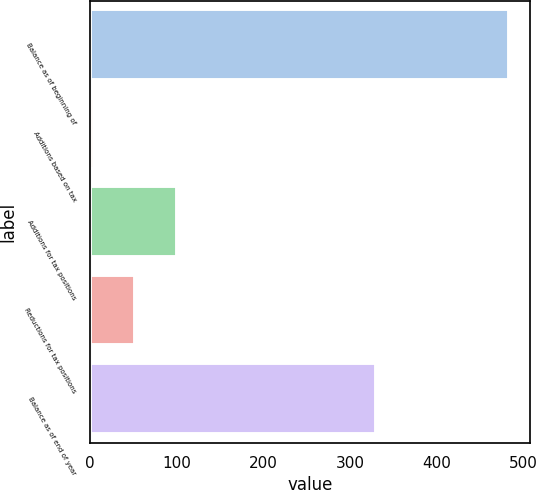<chart> <loc_0><loc_0><loc_500><loc_500><bar_chart><fcel>Balance as of beginning of<fcel>Additions based on tax<fcel>Additions for tax positions<fcel>Reductions for tax positions<fcel>Balance as of end of year<nl><fcel>484<fcel>4<fcel>100<fcel>52<fcel>330<nl></chart> 